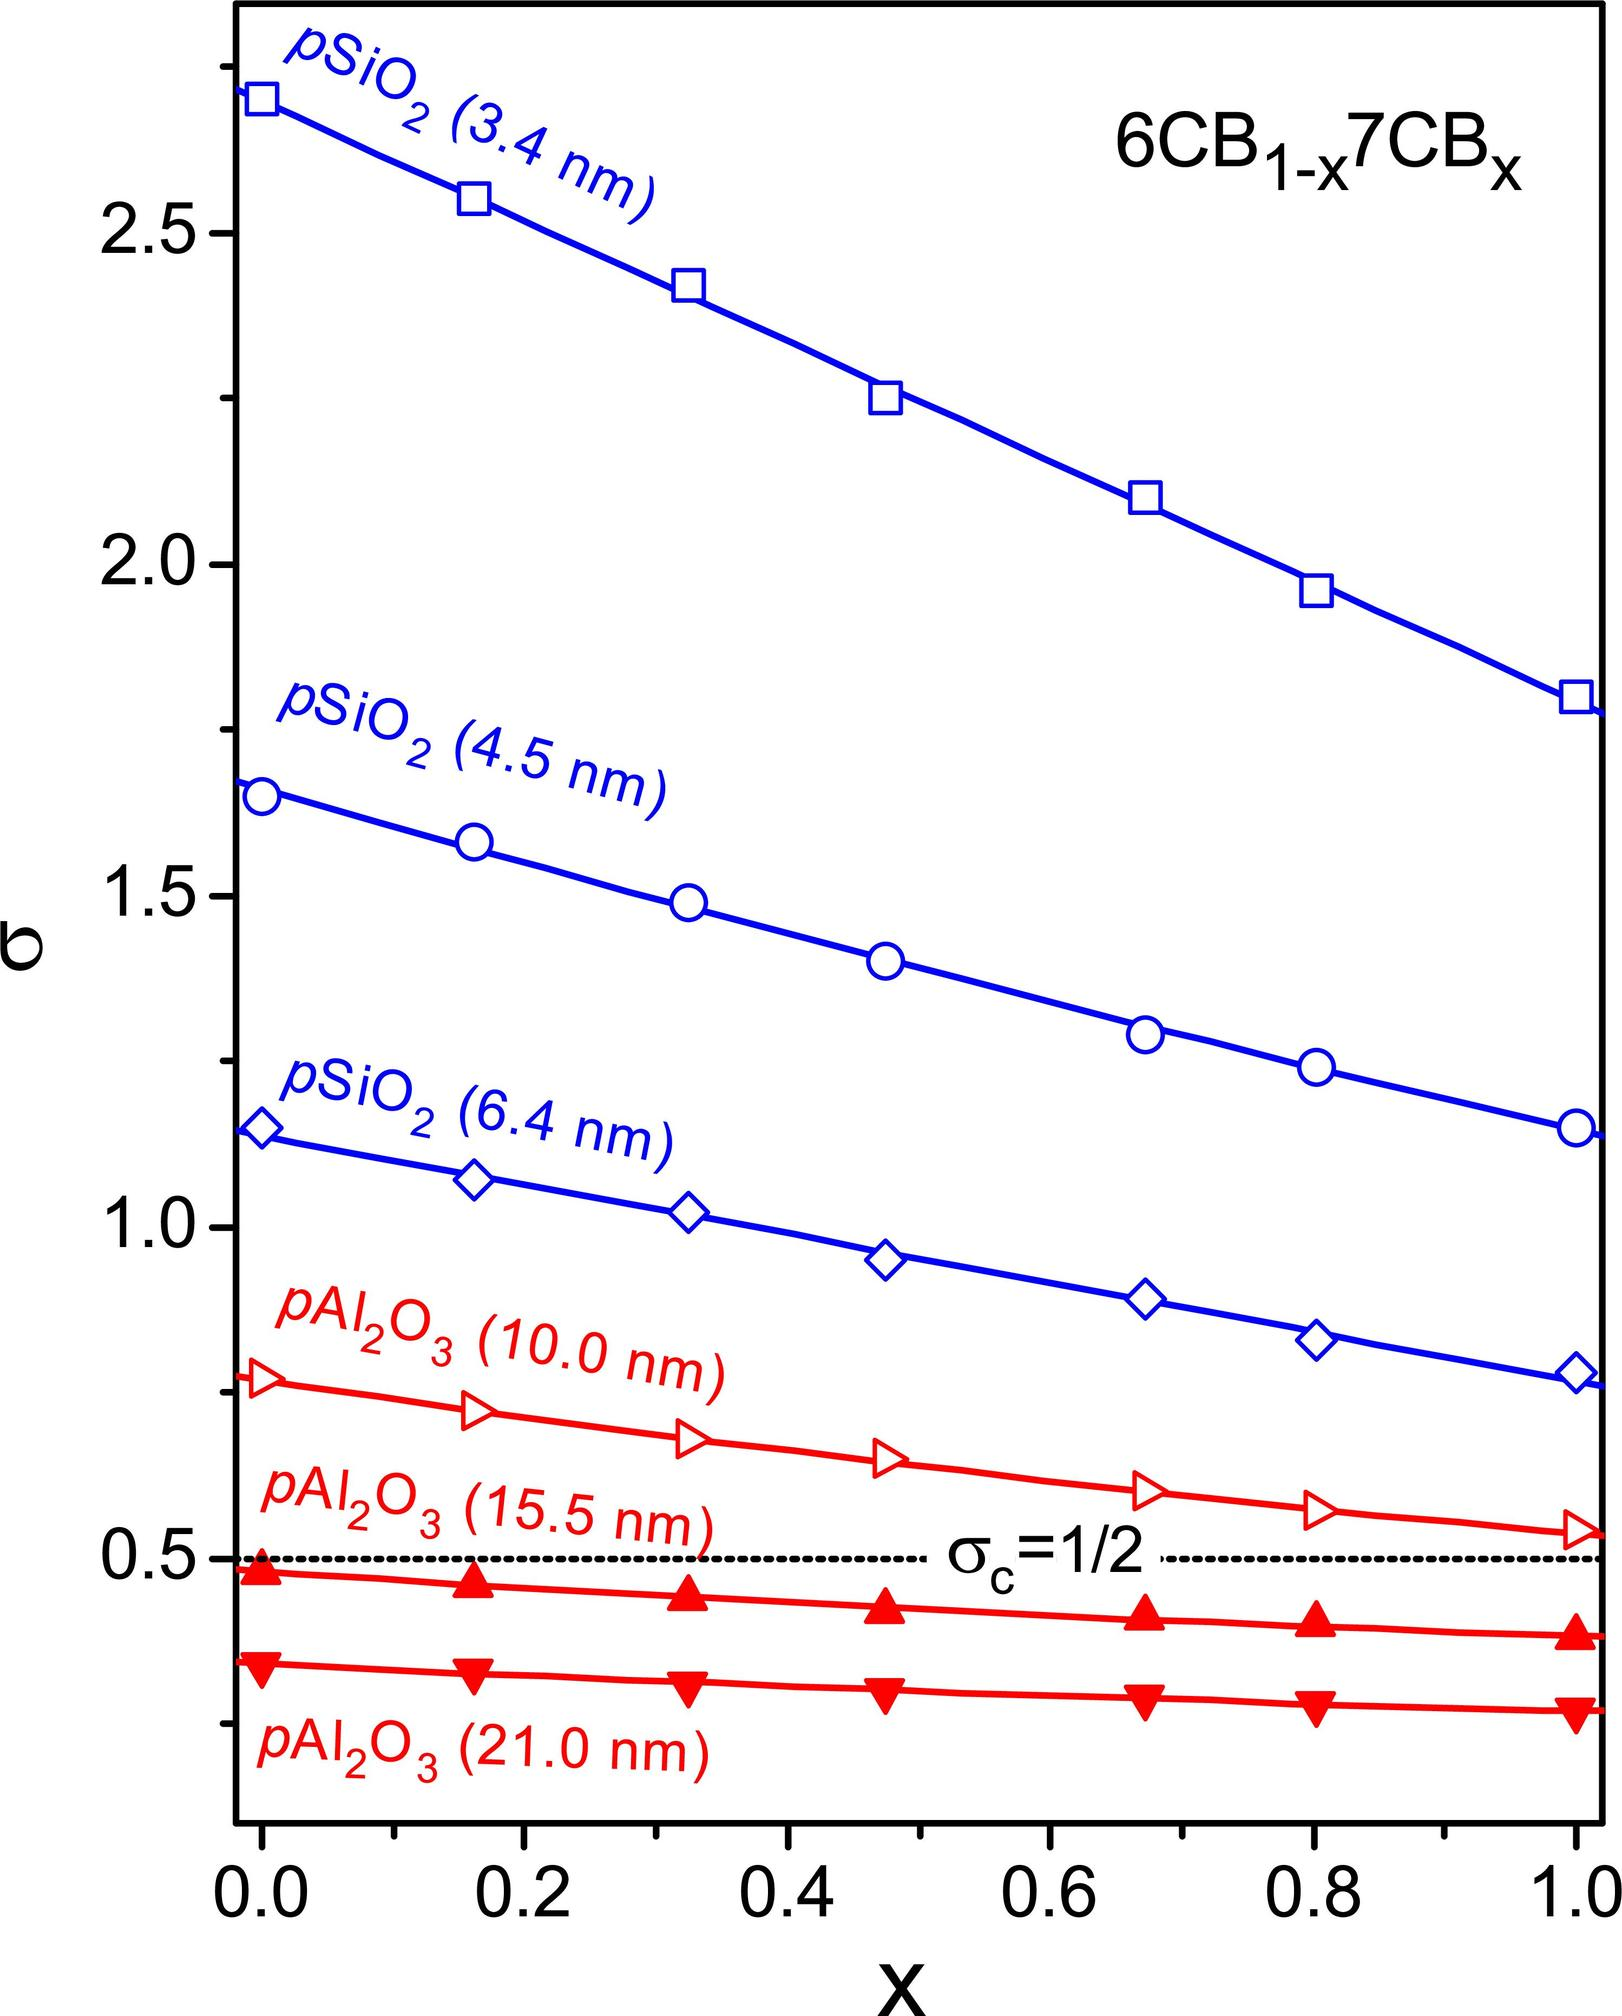What does the parameter 'x' in the figure title "6CB1-x7CBx" most likely represent? A) The concentration of 6CB in moles. B) The fraction of 7CB in the mixture with 6CB. C) The temperature at which the measurements were taken. D) The number of experiments conducted. In chemical notation, a formula such as "6CB1-x7CBx" typically indicates a mixture where 'x' represents the fraction of one component, in this case, 7CB. Since the x-axis of the graph ranges from 0 to 1, this supports the interpretation that 'x' is a fraction, not a temperature or count of experiments. Therefore, the correct answer is B. 